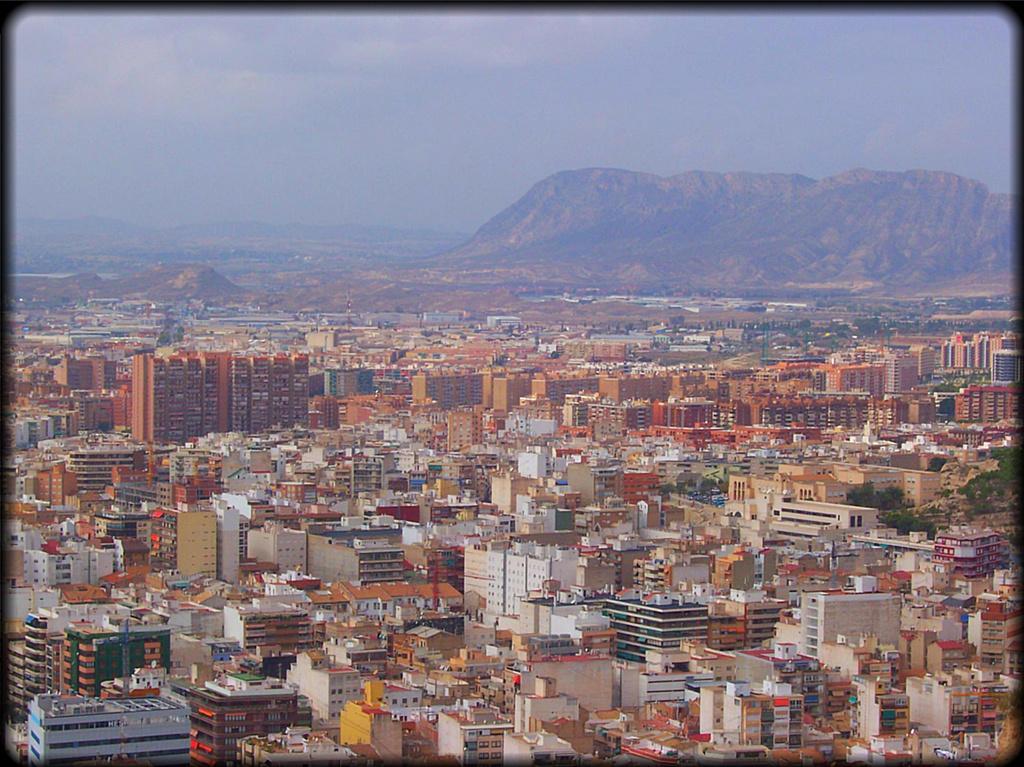Please provide a concise description of this image. This is the picture of a photo and there are some buildings and trees and in the background, we can see the mountains and at the top we can see the sky. 